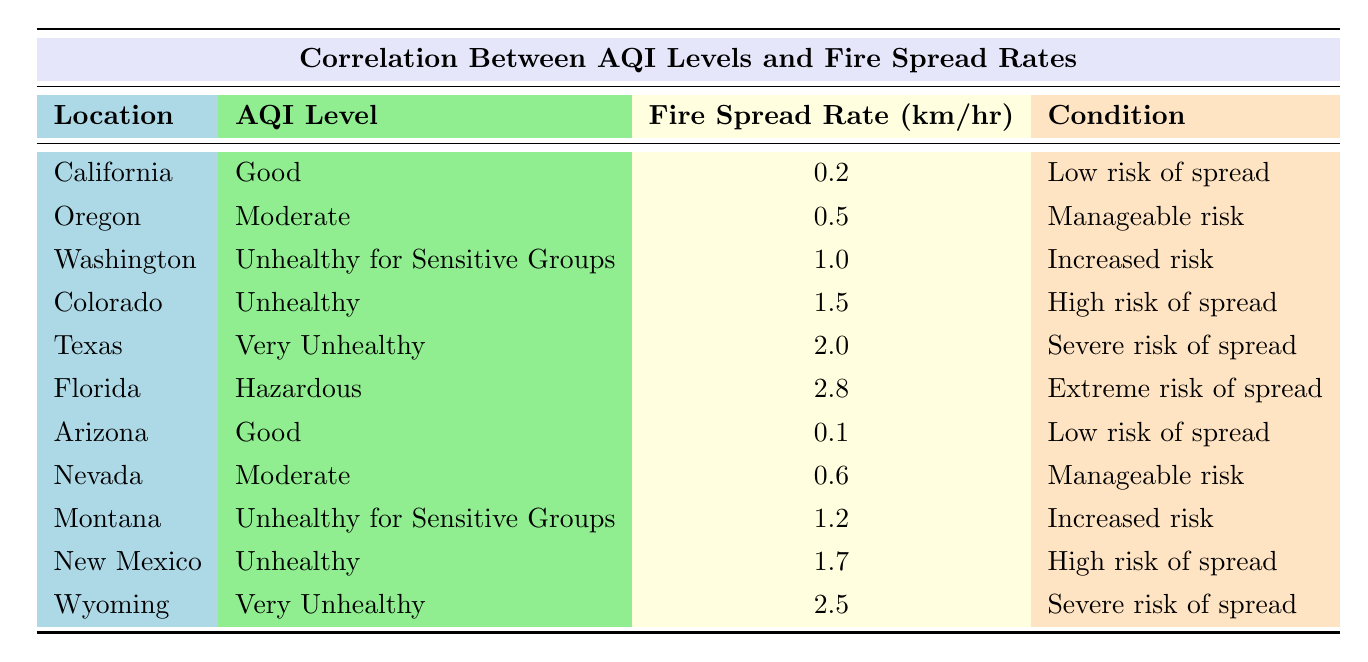What is the fire spread rate for California? The table indicates that California has a fire spread rate of 0.2 km/hr.
Answer: 0.2 km/hr Which location has the highest fire spread rate? By reviewing the table, Florida has the highest fire spread rate at 2.8 km/hr.
Answer: Florida How many locations have an "Unhealthy" AQI Level? The locations with "Unhealthy" AQI levels are Colorado, New Mexico, totaling 2 locations.
Answer: 2 What is the average fire spread rate for locations with a "Good" AQI Level? The fire spread rates for "Good" AQI levels are 0.2 km/hr (California) and 0.1 km/hr (Arizona). The average is (0.2 + 0.1)/2 = 0.15 km/hr.
Answer: 0.15 km/hr Is the fire spread rate for "Hazardous" AQI level higher than that for "Very Unhealthy"? Florida has a fire spread rate of 2.8 km/hr for "Hazardous", while Wyoming has 2.5 km/hr for "Very Unhealthy", thus it is higher.
Answer: Yes What are the fire spread rates for all locations with "Unhealthy for Sensitive Groups"? The fire spread rates for locations with "Unhealthy for Sensitive Groups" are 1.0 km/hr (Washington) and 1.2 km/hr (Montana).
Answer: 1.0 km/hr, 1.2 km/hr If we sum all fire spread rates, what would be the total? Adding all fire spread rates: 0.2 + 0.5 + 1.0 + 1.5 + 2.0 + 2.8 + 0.1 + 0.6 + 1.2 + 1.7 + 2.5 = 14.1 km/hr.
Answer: 14.1 km/hr Which AQI level corresponds to a "High risk of spread"? From the table, "Unhealthy" corresponds to a "High risk of spread", specifically for Colorado and New Mexico.
Answer: Unhealthy How many locations have a "Severe risk of spread" condition? The locations with "Severe risk of spread" are Texas and Wyoming, making it a total of 2 locations.
Answer: 2 What is the difference in fire spread rates between "Good" and "Hazardous" AQI levels? The fire spread rate for "Good" (California: 0.2 km/hr, Arizona: 0.1 km/hr, mean is 0.15 km/hr) compared to "Hazardous" (Florida: 2.8 km/hr) is 2.8 - 0.15 = 2.65 km/hr.
Answer: 2.65 km/hr 